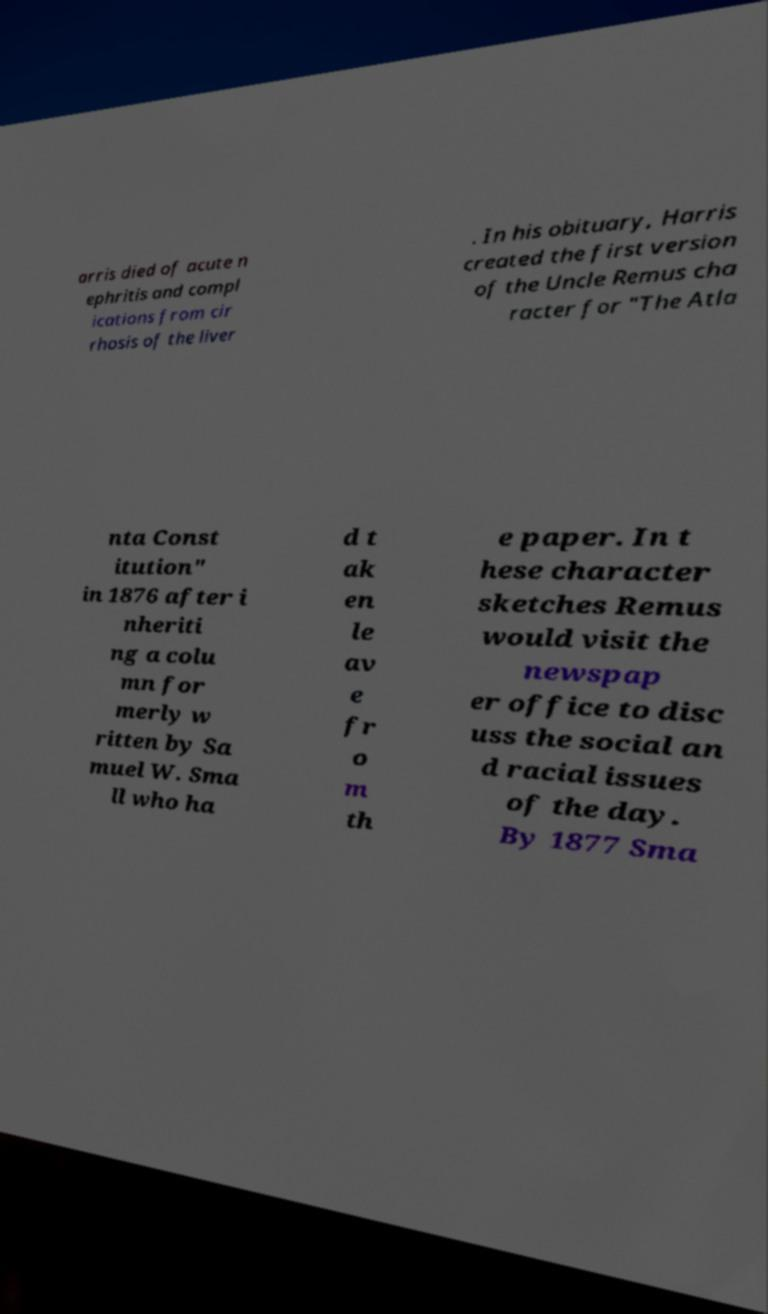Can you read and provide the text displayed in the image?This photo seems to have some interesting text. Can you extract and type it out for me? arris died of acute n ephritis and compl ications from cir rhosis of the liver . In his obituary, Harris created the first version of the Uncle Remus cha racter for "The Atla nta Const itution" in 1876 after i nheriti ng a colu mn for merly w ritten by Sa muel W. Sma ll who ha d t ak en le av e fr o m th e paper. In t hese character sketches Remus would visit the newspap er office to disc uss the social an d racial issues of the day. By 1877 Sma 